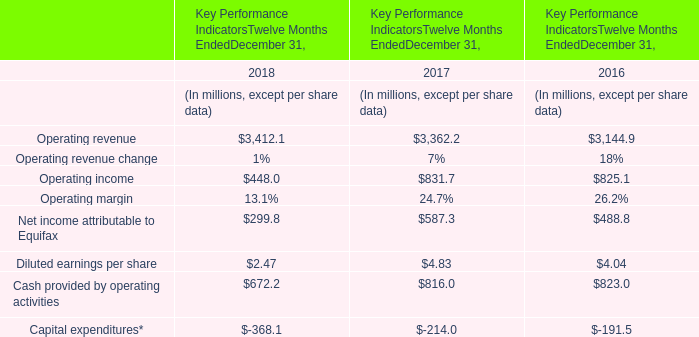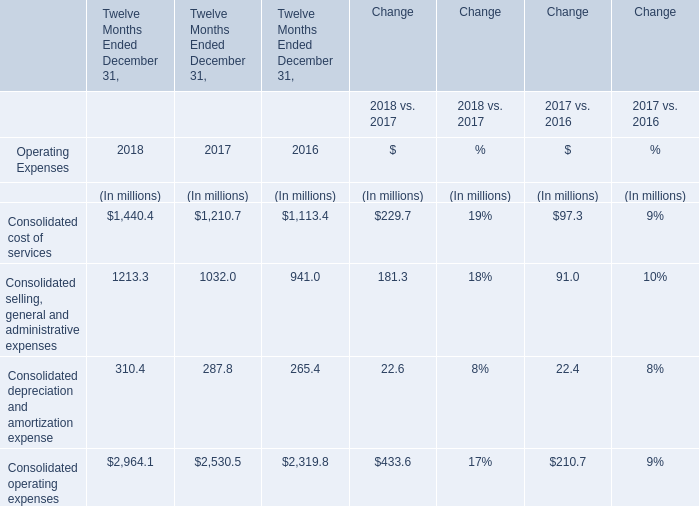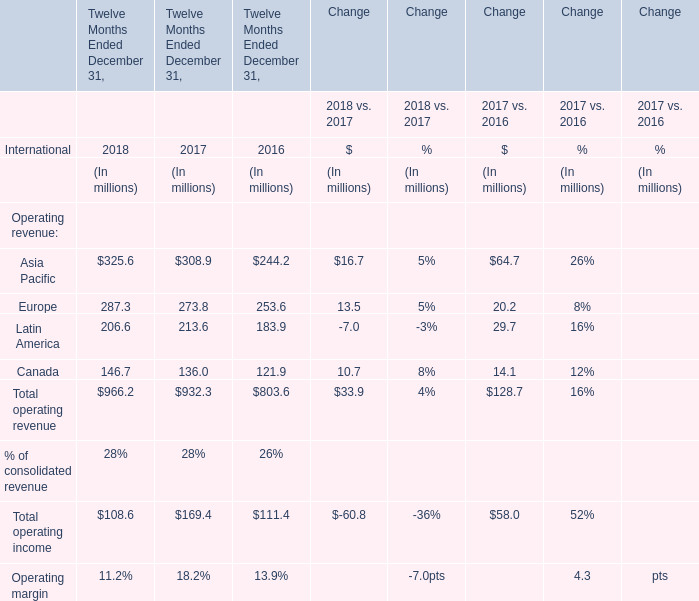when is the highest total amount of operating revenue? 
Answer: 2018. 